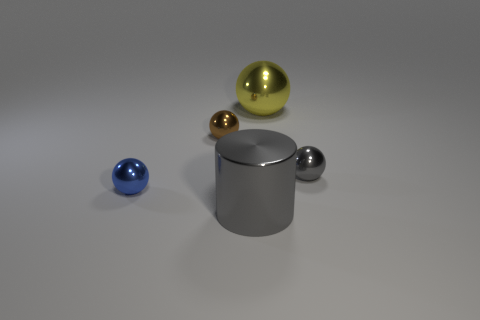Does the image suggest any particular use or purpose for these objects? The image doesn't clearly suggest a practical use or specific purpose for the objects as they seem to be placed for illustrative or artistic purposes, mainly showcasing geometric forms and reflections. Could these objects represent anything symbolically perhaps? Symbolically, the objects could represent elements of balance and simplicity, as there is a harmonious arrangement of shapes and colors. However, any symbolic interpretation would be subjective and could vary greatly from one viewer to another. 